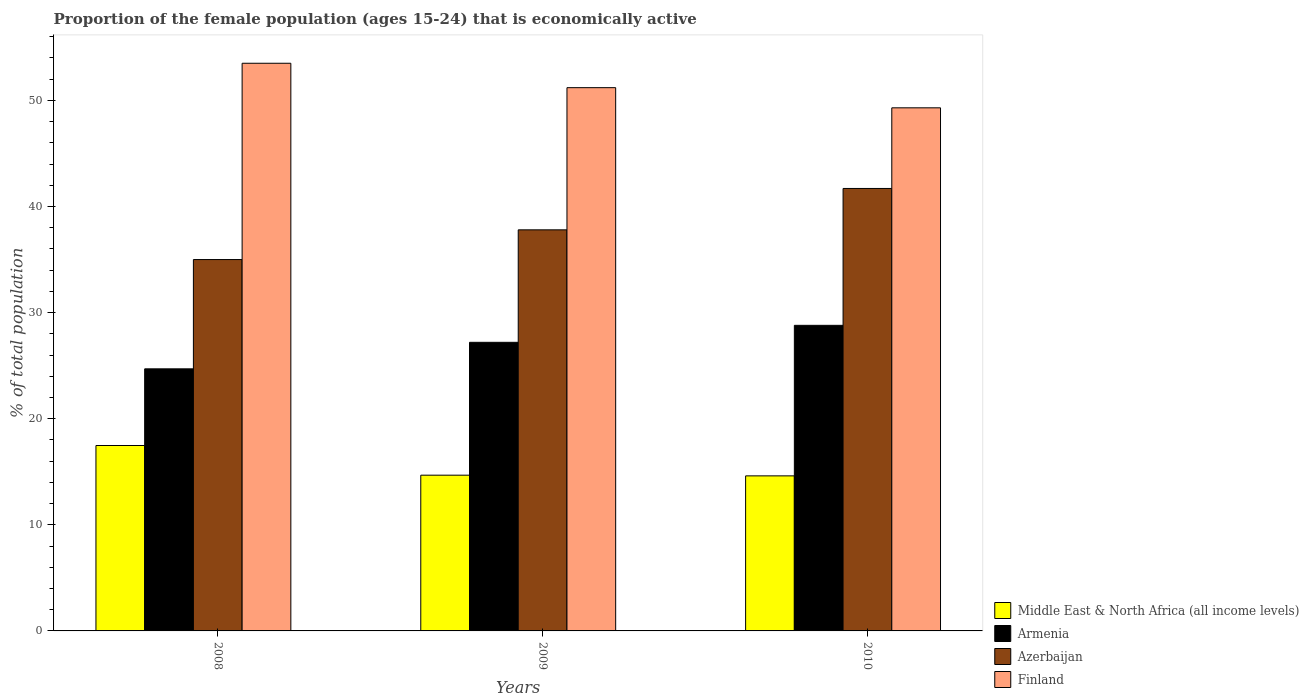Are the number of bars per tick equal to the number of legend labels?
Make the answer very short. Yes. What is the label of the 2nd group of bars from the left?
Your answer should be very brief. 2009. What is the proportion of the female population that is economically active in Middle East & North Africa (all income levels) in 2010?
Your response must be concise. 14.61. Across all years, what is the maximum proportion of the female population that is economically active in Finland?
Your answer should be very brief. 53.5. Across all years, what is the minimum proportion of the female population that is economically active in Middle East & North Africa (all income levels)?
Your response must be concise. 14.61. In which year was the proportion of the female population that is economically active in Middle East & North Africa (all income levels) maximum?
Provide a short and direct response. 2008. What is the total proportion of the female population that is economically active in Armenia in the graph?
Your answer should be compact. 80.7. What is the difference between the proportion of the female population that is economically active in Finland in 2009 and that in 2010?
Offer a very short reply. 1.9. What is the difference between the proportion of the female population that is economically active in Finland in 2008 and the proportion of the female population that is economically active in Azerbaijan in 2009?
Your answer should be very brief. 15.7. What is the average proportion of the female population that is economically active in Middle East & North Africa (all income levels) per year?
Give a very brief answer. 15.59. In the year 2010, what is the difference between the proportion of the female population that is economically active in Finland and proportion of the female population that is economically active in Middle East & North Africa (all income levels)?
Your answer should be very brief. 34.69. In how many years, is the proportion of the female population that is economically active in Armenia greater than 52 %?
Offer a terse response. 0. What is the ratio of the proportion of the female population that is economically active in Azerbaijan in 2008 to that in 2009?
Keep it short and to the point. 0.93. Is the proportion of the female population that is economically active in Azerbaijan in 2008 less than that in 2010?
Ensure brevity in your answer.  Yes. What is the difference between the highest and the second highest proportion of the female population that is economically active in Finland?
Provide a succinct answer. 2.3. What is the difference between the highest and the lowest proportion of the female population that is economically active in Middle East & North Africa (all income levels)?
Offer a terse response. 2.86. In how many years, is the proportion of the female population that is economically active in Middle East & North Africa (all income levels) greater than the average proportion of the female population that is economically active in Middle East & North Africa (all income levels) taken over all years?
Provide a short and direct response. 1. What does the 2nd bar from the right in 2009 represents?
Give a very brief answer. Azerbaijan. Are the values on the major ticks of Y-axis written in scientific E-notation?
Provide a succinct answer. No. Does the graph contain any zero values?
Provide a succinct answer. No. Does the graph contain grids?
Provide a short and direct response. No. How many legend labels are there?
Make the answer very short. 4. What is the title of the graph?
Offer a very short reply. Proportion of the female population (ages 15-24) that is economically active. What is the label or title of the X-axis?
Make the answer very short. Years. What is the label or title of the Y-axis?
Your answer should be very brief. % of total population. What is the % of total population in Middle East & North Africa (all income levels) in 2008?
Your response must be concise. 17.47. What is the % of total population of Armenia in 2008?
Your answer should be compact. 24.7. What is the % of total population of Finland in 2008?
Your response must be concise. 53.5. What is the % of total population of Middle East & North Africa (all income levels) in 2009?
Offer a very short reply. 14.68. What is the % of total population in Armenia in 2009?
Provide a short and direct response. 27.2. What is the % of total population in Azerbaijan in 2009?
Provide a succinct answer. 37.8. What is the % of total population of Finland in 2009?
Your response must be concise. 51.2. What is the % of total population of Middle East & North Africa (all income levels) in 2010?
Provide a succinct answer. 14.61. What is the % of total population in Armenia in 2010?
Ensure brevity in your answer.  28.8. What is the % of total population in Azerbaijan in 2010?
Keep it short and to the point. 41.7. What is the % of total population of Finland in 2010?
Your response must be concise. 49.3. Across all years, what is the maximum % of total population in Middle East & North Africa (all income levels)?
Provide a short and direct response. 17.47. Across all years, what is the maximum % of total population of Armenia?
Offer a very short reply. 28.8. Across all years, what is the maximum % of total population in Azerbaijan?
Your response must be concise. 41.7. Across all years, what is the maximum % of total population in Finland?
Your response must be concise. 53.5. Across all years, what is the minimum % of total population in Middle East & North Africa (all income levels)?
Your response must be concise. 14.61. Across all years, what is the minimum % of total population in Armenia?
Provide a succinct answer. 24.7. Across all years, what is the minimum % of total population of Azerbaijan?
Ensure brevity in your answer.  35. Across all years, what is the minimum % of total population in Finland?
Give a very brief answer. 49.3. What is the total % of total population in Middle East & North Africa (all income levels) in the graph?
Make the answer very short. 46.77. What is the total % of total population of Armenia in the graph?
Provide a short and direct response. 80.7. What is the total % of total population of Azerbaijan in the graph?
Provide a succinct answer. 114.5. What is the total % of total population in Finland in the graph?
Provide a succinct answer. 154. What is the difference between the % of total population in Middle East & North Africa (all income levels) in 2008 and that in 2009?
Keep it short and to the point. 2.8. What is the difference between the % of total population of Finland in 2008 and that in 2009?
Offer a terse response. 2.3. What is the difference between the % of total population in Middle East & North Africa (all income levels) in 2008 and that in 2010?
Your answer should be very brief. 2.86. What is the difference between the % of total population of Armenia in 2008 and that in 2010?
Ensure brevity in your answer.  -4.1. What is the difference between the % of total population of Finland in 2008 and that in 2010?
Provide a short and direct response. 4.2. What is the difference between the % of total population in Middle East & North Africa (all income levels) in 2009 and that in 2010?
Offer a terse response. 0.07. What is the difference between the % of total population of Finland in 2009 and that in 2010?
Keep it short and to the point. 1.9. What is the difference between the % of total population of Middle East & North Africa (all income levels) in 2008 and the % of total population of Armenia in 2009?
Keep it short and to the point. -9.73. What is the difference between the % of total population in Middle East & North Africa (all income levels) in 2008 and the % of total population in Azerbaijan in 2009?
Make the answer very short. -20.33. What is the difference between the % of total population in Middle East & North Africa (all income levels) in 2008 and the % of total population in Finland in 2009?
Make the answer very short. -33.73. What is the difference between the % of total population in Armenia in 2008 and the % of total population in Finland in 2009?
Ensure brevity in your answer.  -26.5. What is the difference between the % of total population in Azerbaijan in 2008 and the % of total population in Finland in 2009?
Your answer should be compact. -16.2. What is the difference between the % of total population of Middle East & North Africa (all income levels) in 2008 and the % of total population of Armenia in 2010?
Give a very brief answer. -11.33. What is the difference between the % of total population of Middle East & North Africa (all income levels) in 2008 and the % of total population of Azerbaijan in 2010?
Give a very brief answer. -24.23. What is the difference between the % of total population in Middle East & North Africa (all income levels) in 2008 and the % of total population in Finland in 2010?
Your answer should be compact. -31.83. What is the difference between the % of total population of Armenia in 2008 and the % of total population of Finland in 2010?
Your answer should be compact. -24.6. What is the difference between the % of total population in Azerbaijan in 2008 and the % of total population in Finland in 2010?
Give a very brief answer. -14.3. What is the difference between the % of total population of Middle East & North Africa (all income levels) in 2009 and the % of total population of Armenia in 2010?
Provide a short and direct response. -14.12. What is the difference between the % of total population in Middle East & North Africa (all income levels) in 2009 and the % of total population in Azerbaijan in 2010?
Your answer should be very brief. -27.02. What is the difference between the % of total population of Middle East & North Africa (all income levels) in 2009 and the % of total population of Finland in 2010?
Your response must be concise. -34.62. What is the difference between the % of total population of Armenia in 2009 and the % of total population of Finland in 2010?
Make the answer very short. -22.1. What is the difference between the % of total population of Azerbaijan in 2009 and the % of total population of Finland in 2010?
Ensure brevity in your answer.  -11.5. What is the average % of total population of Middle East & North Africa (all income levels) per year?
Your answer should be compact. 15.59. What is the average % of total population in Armenia per year?
Provide a succinct answer. 26.9. What is the average % of total population of Azerbaijan per year?
Offer a very short reply. 38.17. What is the average % of total population of Finland per year?
Your answer should be very brief. 51.33. In the year 2008, what is the difference between the % of total population in Middle East & North Africa (all income levels) and % of total population in Armenia?
Your answer should be very brief. -7.23. In the year 2008, what is the difference between the % of total population in Middle East & North Africa (all income levels) and % of total population in Azerbaijan?
Make the answer very short. -17.53. In the year 2008, what is the difference between the % of total population of Middle East & North Africa (all income levels) and % of total population of Finland?
Offer a terse response. -36.03. In the year 2008, what is the difference between the % of total population in Armenia and % of total population in Finland?
Your answer should be compact. -28.8. In the year 2008, what is the difference between the % of total population of Azerbaijan and % of total population of Finland?
Keep it short and to the point. -18.5. In the year 2009, what is the difference between the % of total population of Middle East & North Africa (all income levels) and % of total population of Armenia?
Your response must be concise. -12.52. In the year 2009, what is the difference between the % of total population of Middle East & North Africa (all income levels) and % of total population of Azerbaijan?
Offer a very short reply. -23.12. In the year 2009, what is the difference between the % of total population in Middle East & North Africa (all income levels) and % of total population in Finland?
Your answer should be very brief. -36.52. In the year 2009, what is the difference between the % of total population in Armenia and % of total population in Finland?
Your answer should be very brief. -24. In the year 2010, what is the difference between the % of total population of Middle East & North Africa (all income levels) and % of total population of Armenia?
Provide a succinct answer. -14.19. In the year 2010, what is the difference between the % of total population in Middle East & North Africa (all income levels) and % of total population in Azerbaijan?
Offer a terse response. -27.09. In the year 2010, what is the difference between the % of total population of Middle East & North Africa (all income levels) and % of total population of Finland?
Ensure brevity in your answer.  -34.69. In the year 2010, what is the difference between the % of total population of Armenia and % of total population of Azerbaijan?
Your response must be concise. -12.9. In the year 2010, what is the difference between the % of total population of Armenia and % of total population of Finland?
Your answer should be very brief. -20.5. What is the ratio of the % of total population in Middle East & North Africa (all income levels) in 2008 to that in 2009?
Your response must be concise. 1.19. What is the ratio of the % of total population in Armenia in 2008 to that in 2009?
Give a very brief answer. 0.91. What is the ratio of the % of total population of Azerbaijan in 2008 to that in 2009?
Your response must be concise. 0.93. What is the ratio of the % of total population in Finland in 2008 to that in 2009?
Your answer should be very brief. 1.04. What is the ratio of the % of total population in Middle East & North Africa (all income levels) in 2008 to that in 2010?
Your answer should be very brief. 1.2. What is the ratio of the % of total population in Armenia in 2008 to that in 2010?
Your answer should be compact. 0.86. What is the ratio of the % of total population in Azerbaijan in 2008 to that in 2010?
Offer a terse response. 0.84. What is the ratio of the % of total population in Finland in 2008 to that in 2010?
Ensure brevity in your answer.  1.09. What is the ratio of the % of total population of Middle East & North Africa (all income levels) in 2009 to that in 2010?
Ensure brevity in your answer.  1. What is the ratio of the % of total population in Armenia in 2009 to that in 2010?
Give a very brief answer. 0.94. What is the ratio of the % of total population of Azerbaijan in 2009 to that in 2010?
Make the answer very short. 0.91. What is the difference between the highest and the second highest % of total population in Middle East & North Africa (all income levels)?
Provide a short and direct response. 2.8. What is the difference between the highest and the second highest % of total population in Armenia?
Make the answer very short. 1.6. What is the difference between the highest and the second highest % of total population of Azerbaijan?
Your answer should be very brief. 3.9. What is the difference between the highest and the second highest % of total population in Finland?
Offer a very short reply. 2.3. What is the difference between the highest and the lowest % of total population of Middle East & North Africa (all income levels)?
Make the answer very short. 2.86. What is the difference between the highest and the lowest % of total population of Armenia?
Your response must be concise. 4.1. What is the difference between the highest and the lowest % of total population in Finland?
Ensure brevity in your answer.  4.2. 